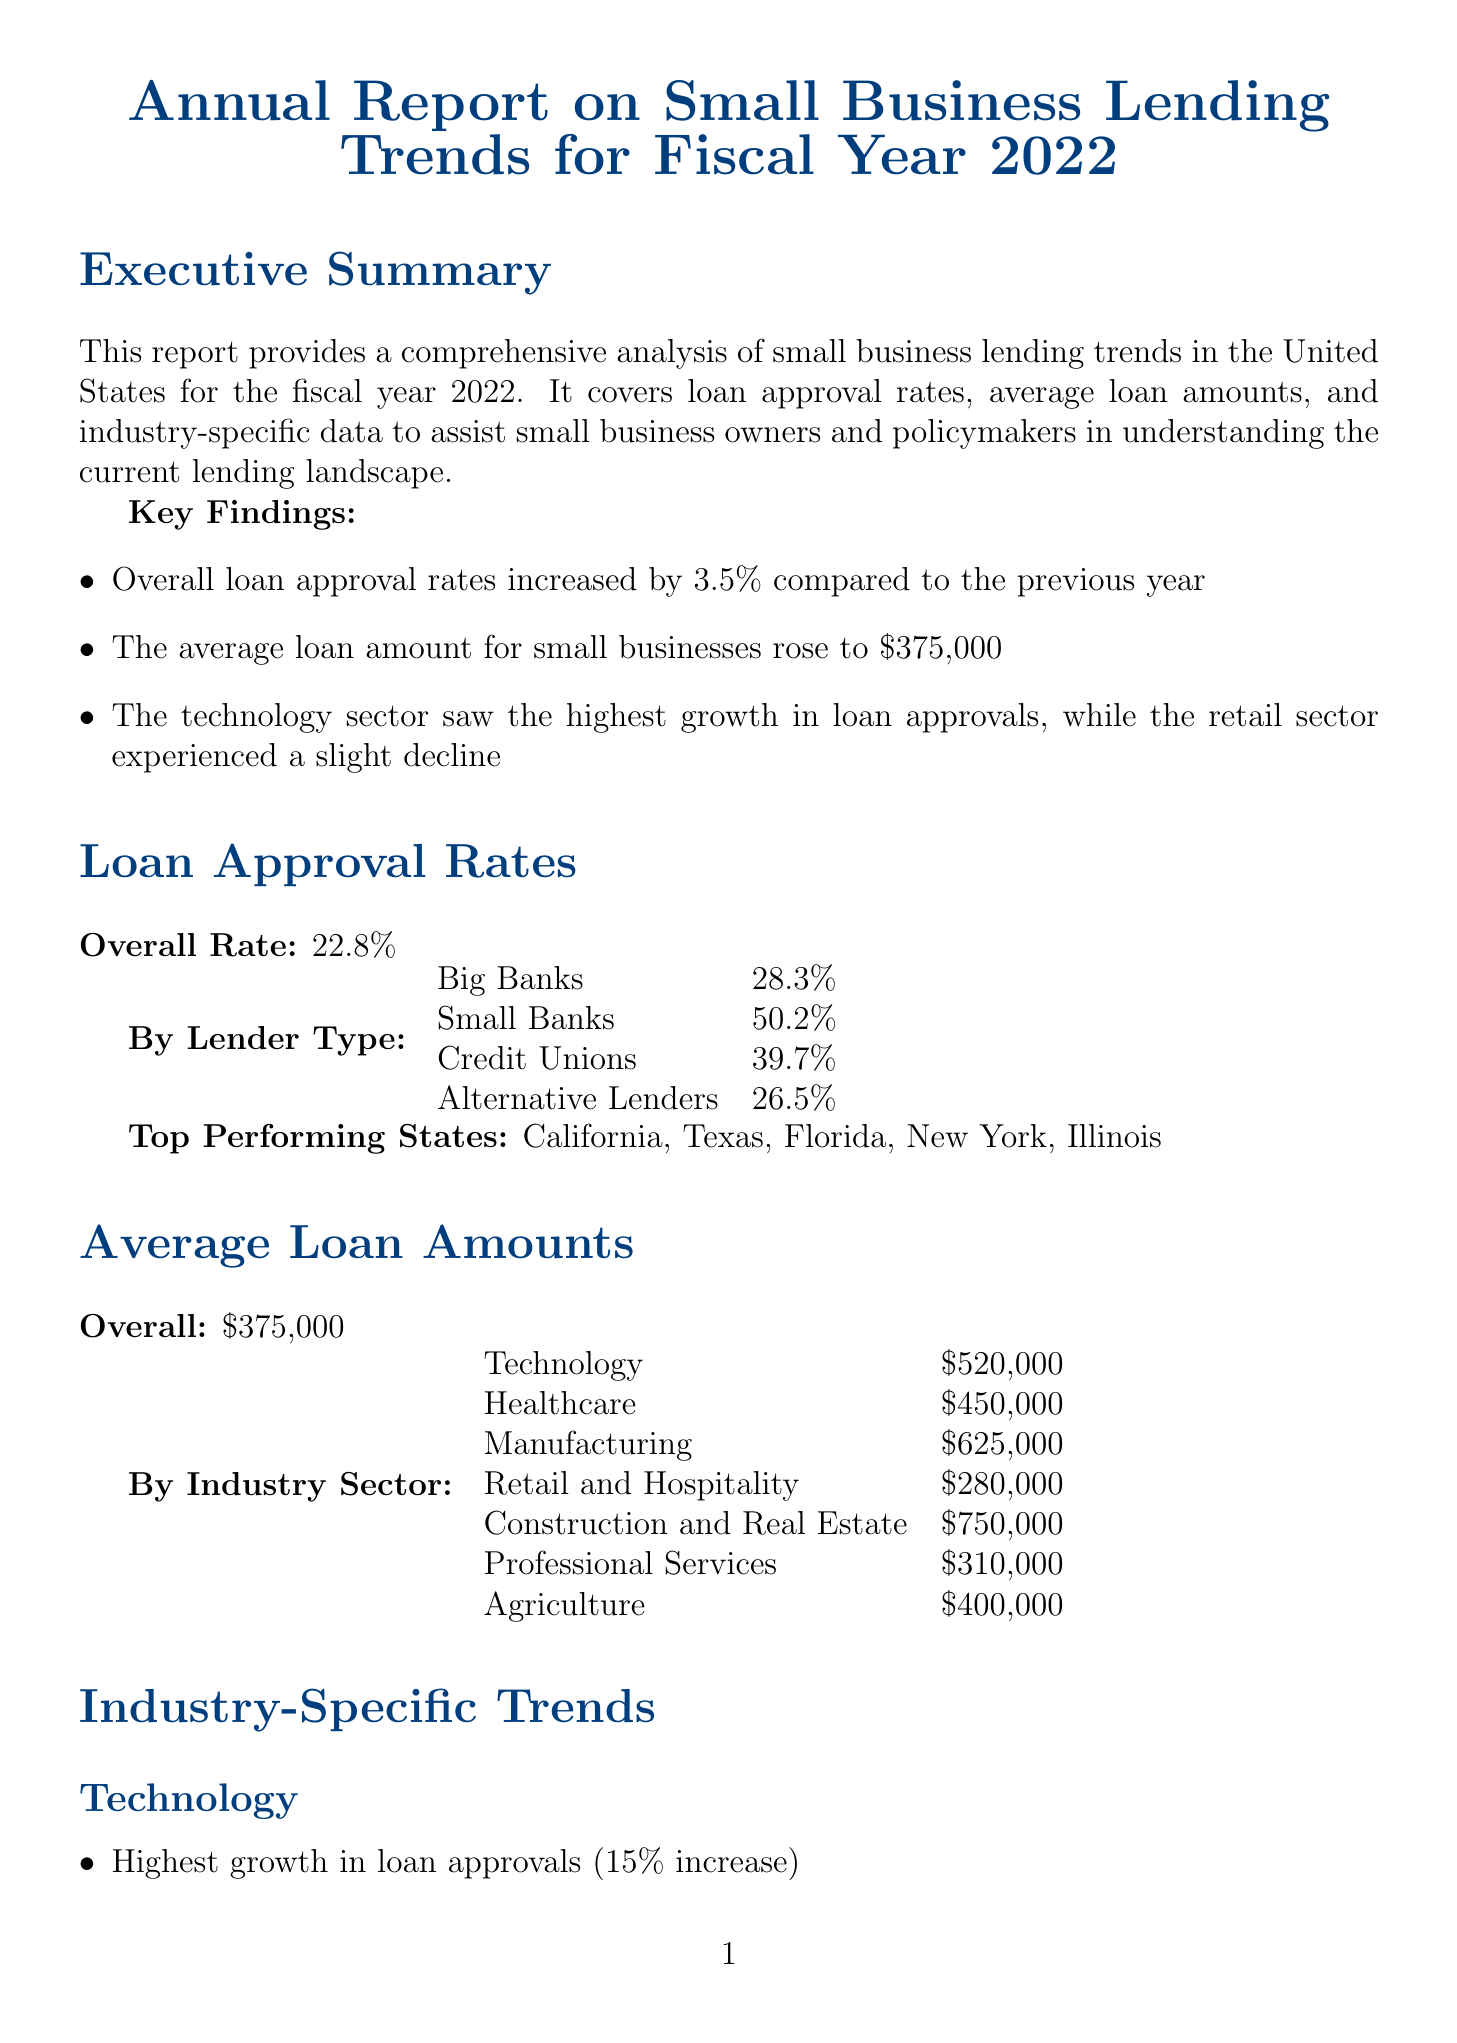What is the report title? The title of the report is mentioned at the beginning, indicating the focus on small business lending trends for a specific fiscal year.
Answer: Annual Report on Small Business Lending Trends for Fiscal Year 2022 What was the overall loan approval rate for fiscal year 2022? The report states the overall loan approval rate as a percentage, providing a benchmark for the lending landscape.
Answer: 22.8% Which sector had the highest average loan amount? The document lists average loan amounts by industry, allowing for comparisons of different sectors.
Answer: Construction and Real Estate What was the approval rate for the Microloan Program? The report includes specific approval rates for various SBA lending programs, highlighting their performance.
Answer: 55.8% What challenge is related to economic uncertainties? The report addresses ongoing challenges facing small businesses, especially related to external economic factors.
Answer: Ongoing economic uncertainty due to global events How much did the average loan amount in the healthcare sector decrease by? The information covers industry trends and changes in average loan amounts, reflecting shifts in the lending market.
Answer: 2% What is one of the recommended actions for enhancing support to small business owners? The recommendations section outlines strategic actions to improve lending and support services for small businesses.
Answer: Enhance financial education programs for small business owners Which state was identified as a top-performing state for loan approvals? The document lists specific states that have high loan approval rates, aiding in geographic analysis of lending trends.
Answer: California 